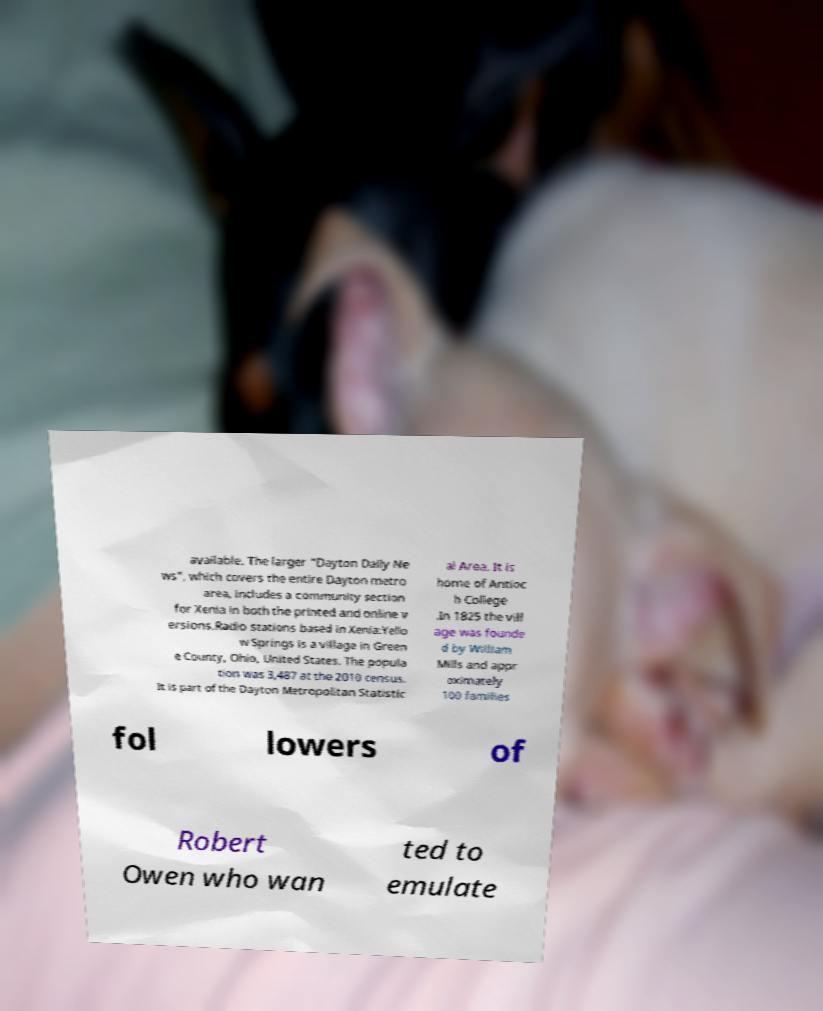I need the written content from this picture converted into text. Can you do that? available. The larger "Dayton Daily Ne ws", which covers the entire Dayton metro area, includes a community section for Xenia in both the printed and online v ersions.Radio stations based in Xenia:Yello w Springs is a village in Green e County, Ohio, United States. The popula tion was 3,487 at the 2010 census. It is part of the Dayton Metropolitan Statistic al Area. It is home of Antioc h College .In 1825 the vill age was founde d by William Mills and appr oximately 100 families fol lowers of Robert Owen who wan ted to emulate 